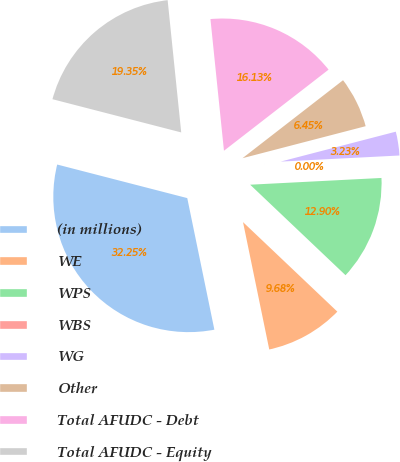Convert chart. <chart><loc_0><loc_0><loc_500><loc_500><pie_chart><fcel>(in millions)<fcel>WE<fcel>WPS<fcel>WBS<fcel>WG<fcel>Other<fcel>Total AFUDC - Debt<fcel>Total AFUDC - Equity<nl><fcel>32.25%<fcel>9.68%<fcel>12.9%<fcel>0.0%<fcel>3.23%<fcel>6.45%<fcel>16.13%<fcel>19.35%<nl></chart> 